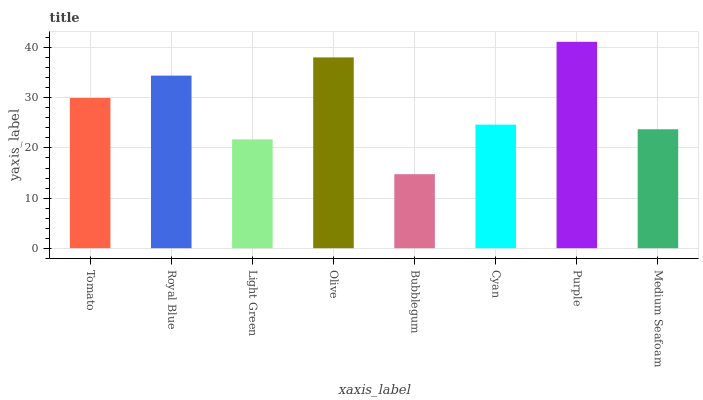Is Bubblegum the minimum?
Answer yes or no. Yes. Is Purple the maximum?
Answer yes or no. Yes. Is Royal Blue the minimum?
Answer yes or no. No. Is Royal Blue the maximum?
Answer yes or no. No. Is Royal Blue greater than Tomato?
Answer yes or no. Yes. Is Tomato less than Royal Blue?
Answer yes or no. Yes. Is Tomato greater than Royal Blue?
Answer yes or no. No. Is Royal Blue less than Tomato?
Answer yes or no. No. Is Tomato the high median?
Answer yes or no. Yes. Is Cyan the low median?
Answer yes or no. Yes. Is Bubblegum the high median?
Answer yes or no. No. Is Royal Blue the low median?
Answer yes or no. No. 